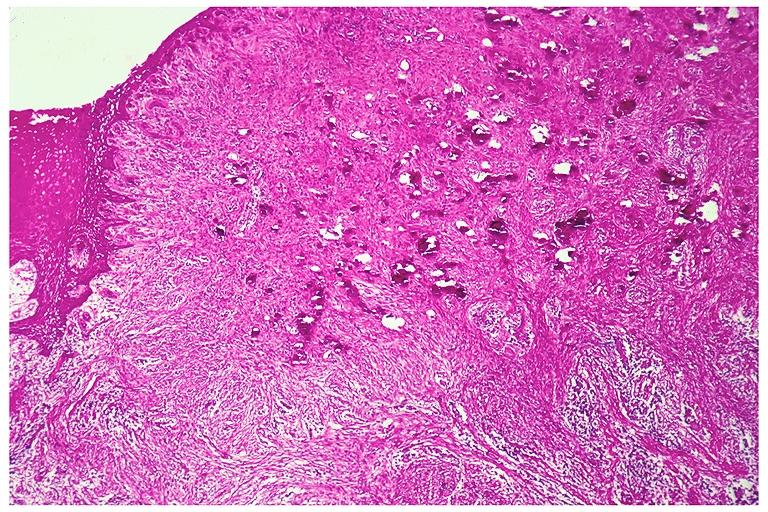what is present?
Answer the question using a single word or phrase. Oral 